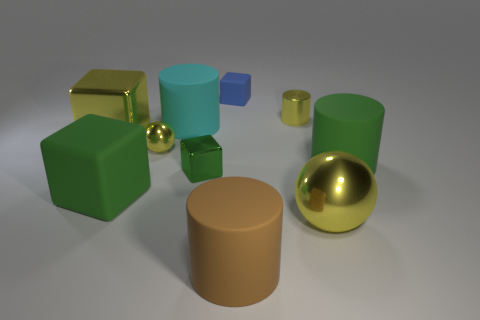Subtract 1 blocks. How many blocks are left? 3 Subtract all cylinders. How many objects are left? 6 Subtract 0 red spheres. How many objects are left? 10 Subtract all big blue metal spheres. Subtract all brown rubber cylinders. How many objects are left? 9 Add 3 cylinders. How many cylinders are left? 7 Add 6 large yellow spheres. How many large yellow spheres exist? 7 